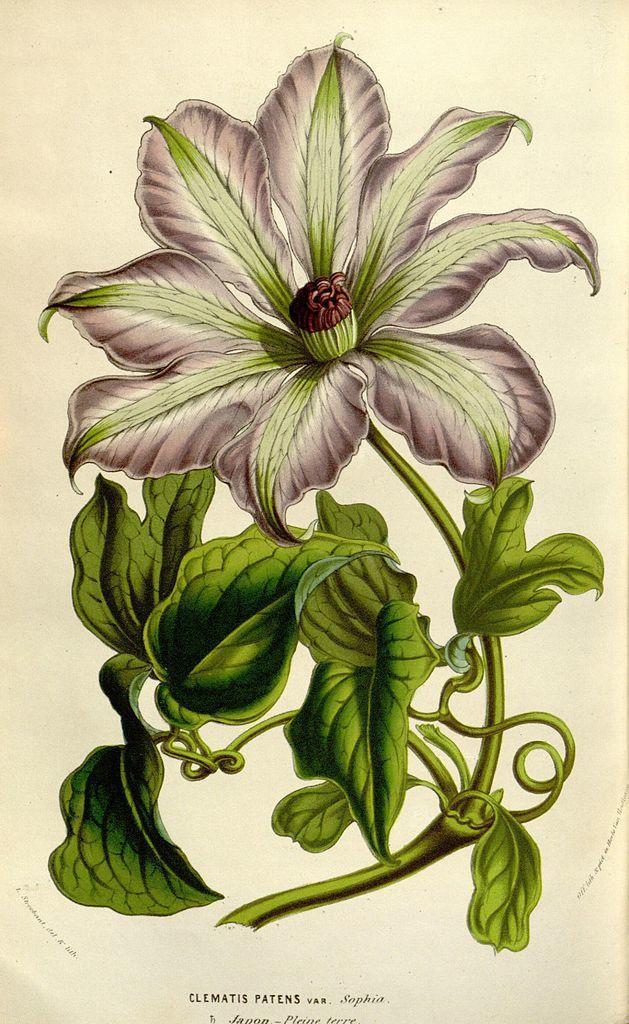Describe this image in one or two sentences. In this image there is a drawing of a flower, in the bottom there is a text written. 